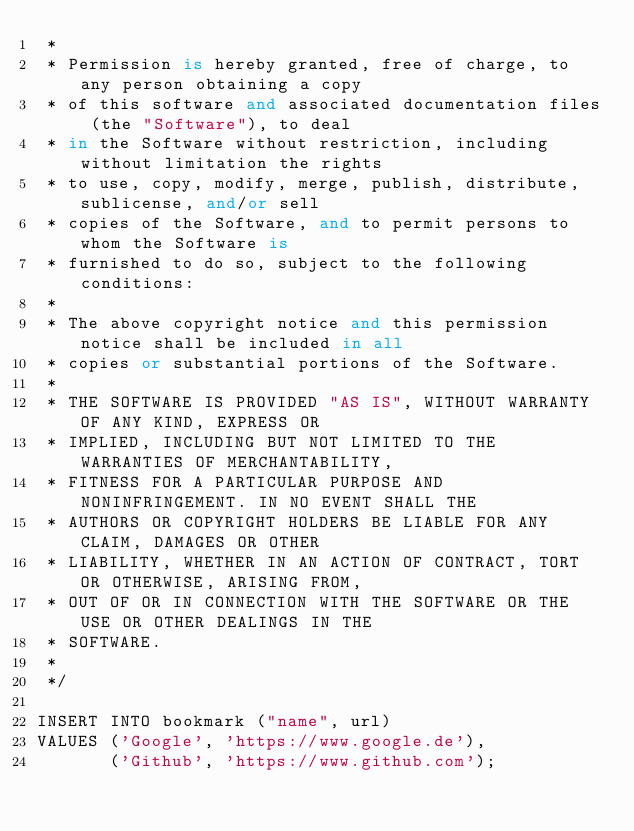<code> <loc_0><loc_0><loc_500><loc_500><_SQL_> *
 * Permission is hereby granted, free of charge, to any person obtaining a copy
 * of this software and associated documentation files (the "Software"), to deal
 * in the Software without restriction, including without limitation the rights
 * to use, copy, modify, merge, publish, distribute, sublicense, and/or sell
 * copies of the Software, and to permit persons to whom the Software is
 * furnished to do so, subject to the following conditions:
 *
 * The above copyright notice and this permission notice shall be included in all
 * copies or substantial portions of the Software.
 *
 * THE SOFTWARE IS PROVIDED "AS IS", WITHOUT WARRANTY OF ANY KIND, EXPRESS OR
 * IMPLIED, INCLUDING BUT NOT LIMITED TO THE WARRANTIES OF MERCHANTABILITY,
 * FITNESS FOR A PARTICULAR PURPOSE AND NONINFRINGEMENT. IN NO EVENT SHALL THE
 * AUTHORS OR COPYRIGHT HOLDERS BE LIABLE FOR ANY CLAIM, DAMAGES OR OTHER
 * LIABILITY, WHETHER IN AN ACTION OF CONTRACT, TORT OR OTHERWISE, ARISING FROM,
 * OUT OF OR IN CONNECTION WITH THE SOFTWARE OR THE USE OR OTHER DEALINGS IN THE
 * SOFTWARE.
 *
 */

INSERT INTO bookmark ("name", url)
VALUES ('Google', 'https://www.google.de'),
       ('Github', 'https://www.github.com');
</code> 